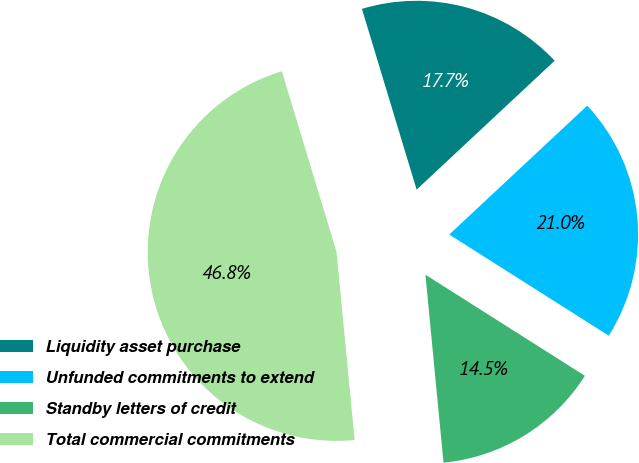Convert chart to OTSL. <chart><loc_0><loc_0><loc_500><loc_500><pie_chart><fcel>Liquidity asset purchase<fcel>Unfunded commitments to extend<fcel>Standby letters of credit<fcel>Total commercial commitments<nl><fcel>17.72%<fcel>20.95%<fcel>14.48%<fcel>46.85%<nl></chart> 